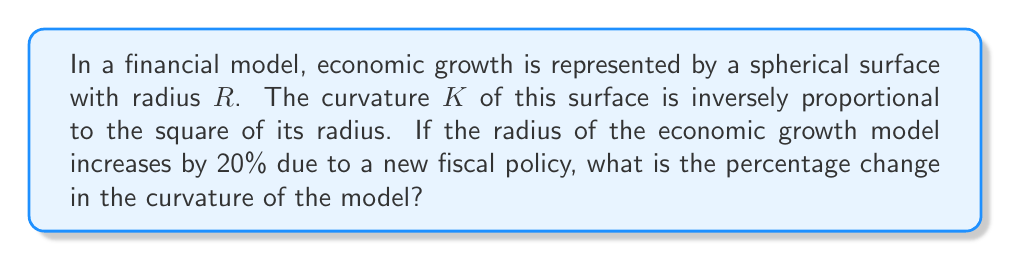Solve this math problem. Let's approach this step-by-step:

1) The curvature $K$ of a sphere is given by:

   $$K = \frac{1}{R^2}$$

2) Let's denote the initial radius as $R$ and the new radius as $R_{new}$.
   We know that $R_{new}$ is 20% larger than $R$:

   $$R_{new} = 1.2R$$

3) The initial curvature $K$ is:

   $$K = \frac{1}{R^2}$$

4) The new curvature $K_{new}$ is:

   $$K_{new} = \frac{1}{R_{new}^2} = \frac{1}{(1.2R)^2} = \frac{1}{1.44R^2}$$

5) To find the percentage change, we use the formula:

   $$\text{Percentage Change} = \frac{\text{New Value} - \text{Original Value}}{\text{Original Value}} \times 100\%$$

6) Substituting our curvature values:

   $$\text{Percentage Change} = \frac{K_{new} - K}{K} \times 100\%$$
   
   $$= \frac{\frac{1}{1.44R^2} - \frac{1}{R^2}}{\frac{1}{R^2}} \times 100\%$$

7) Simplifying:

   $$= \left(\frac{1}{1.44} - 1\right) \times 100\% = \left(\frac{1}{1.44} - \frac{144}{144}\right) \times 100\%$$
   
   $$= \left(\frac{100}{144} - \frac{144}{144}\right) \times 100\% = \left(-\frac{44}{144}\right) \times 100\% = -30.56\%$$

Thus, the curvature decreases by approximately 30.56%.
Answer: -30.56% 